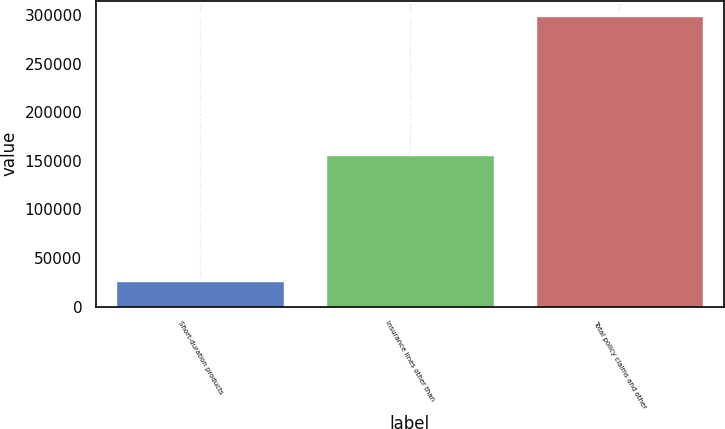Convert chart to OTSL. <chart><loc_0><loc_0><loc_500><loc_500><bar_chart><fcel>Short-duration products<fcel>Insurance lines other than<fcel>Total policy claims and other<nl><fcel>26721<fcel>156437<fcel>299565<nl></chart> 